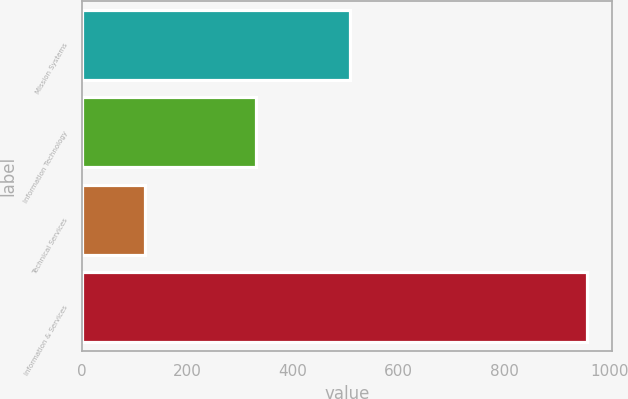<chart> <loc_0><loc_0><loc_500><loc_500><bar_chart><fcel>Mission Systems<fcel>Information Technology<fcel>Technical Services<fcel>Information & Services<nl><fcel>508<fcel>329<fcel>120<fcel>957<nl></chart> 